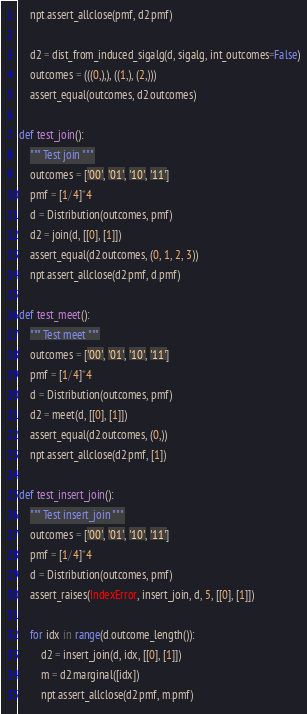<code> <loc_0><loc_0><loc_500><loc_500><_Python_>    npt.assert_allclose(pmf, d2.pmf)

    d2 = dist_from_induced_sigalg(d, sigalg, int_outcomes=False)
    outcomes = (((0,),), ((1,), (2,)))
    assert_equal(outcomes, d2.outcomes)

def test_join():
    """ Test join """
    outcomes = ['00', '01', '10', '11']
    pmf = [1/4]*4
    d = Distribution(outcomes, pmf)
    d2 = join(d, [[0], [1]])
    assert_equal(d2.outcomes, (0, 1, 2, 3))
    npt.assert_allclose(d2.pmf, d.pmf)

def test_meet():
    """ Test meet """
    outcomes = ['00', '01', '10', '11']
    pmf = [1/4]*4
    d = Distribution(outcomes, pmf)
    d2 = meet(d, [[0], [1]])
    assert_equal(d2.outcomes, (0,))
    npt.assert_allclose(d2.pmf, [1])

def test_insert_join():
    """ Test insert_join """
    outcomes = ['00', '01', '10', '11']
    pmf = [1/4]*4
    d = Distribution(outcomes, pmf)
    assert_raises(IndexError, insert_join, d, 5, [[0], [1]])

    for idx in range(d.outcome_length()):
        d2 = insert_join(d, idx, [[0], [1]])
        m = d2.marginal([idx])
        npt.assert_allclose(d2.pmf, m.pmf)
</code> 